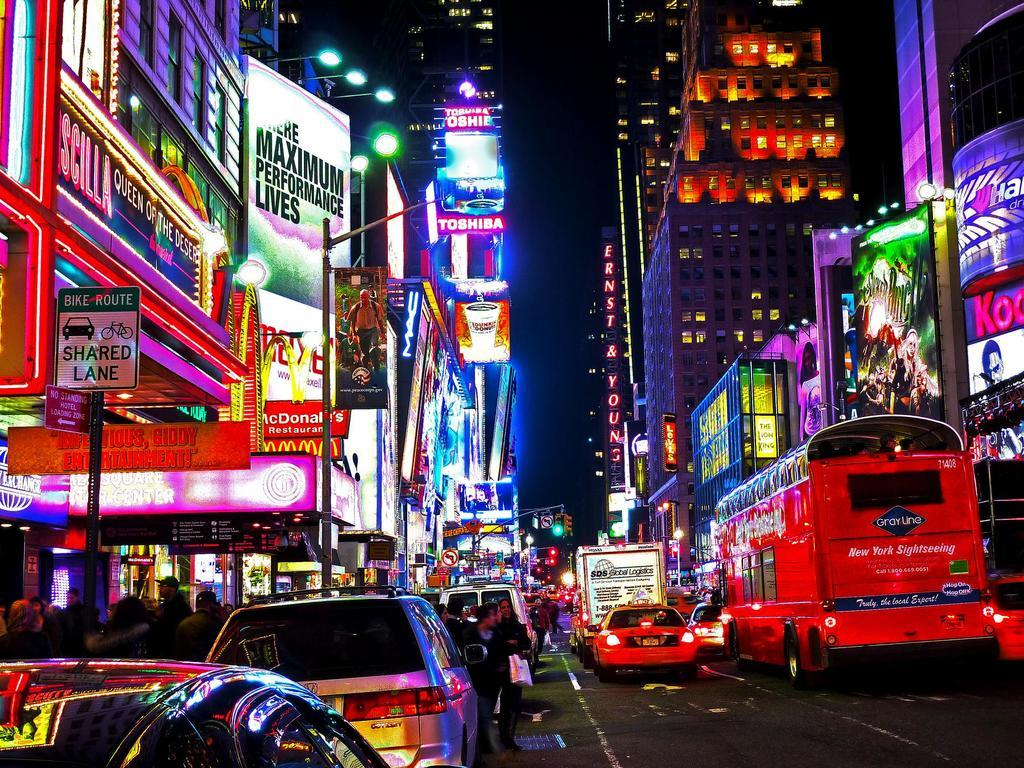<image>
Present a compact description of the photo's key features. A nighttime city street scene with a marquee for Priscilla Queen of the Desert. 